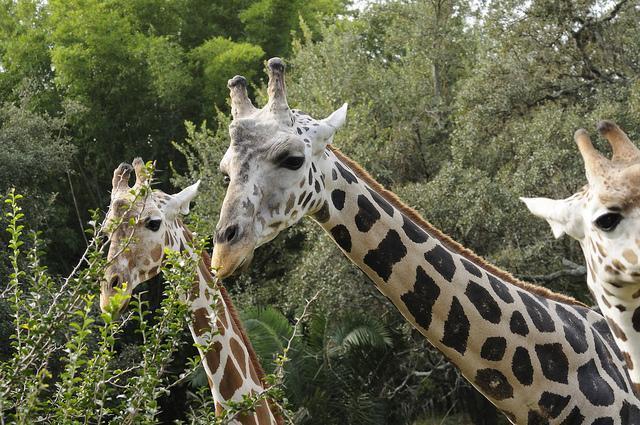How many horns do the giraffe have?
Give a very brief answer. 2. How many giraffes are visible?
Give a very brief answer. 3. How many zebras are facing the camera?
Give a very brief answer. 0. 